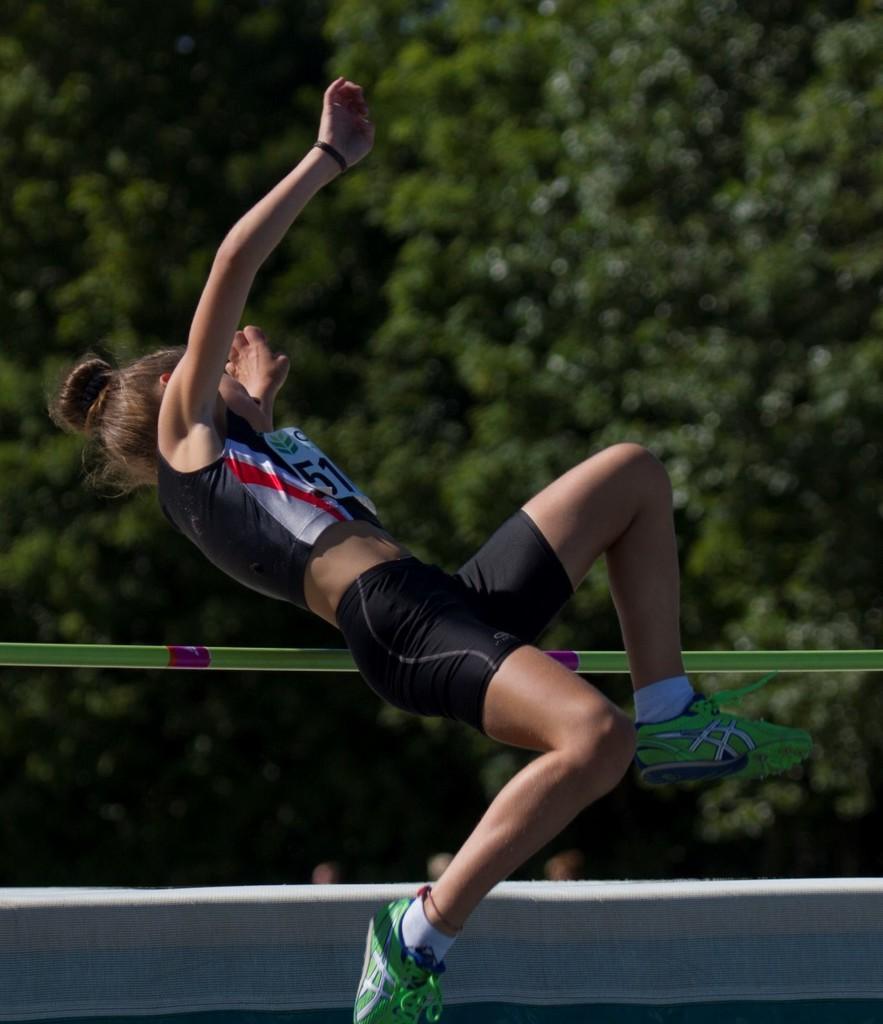In one or two sentences, can you explain what this image depicts? In the image there is a lady with shoes and white paper with a number is in the air. Behind her there is a rope. At the bottom there is an object. There are trees in the background. 